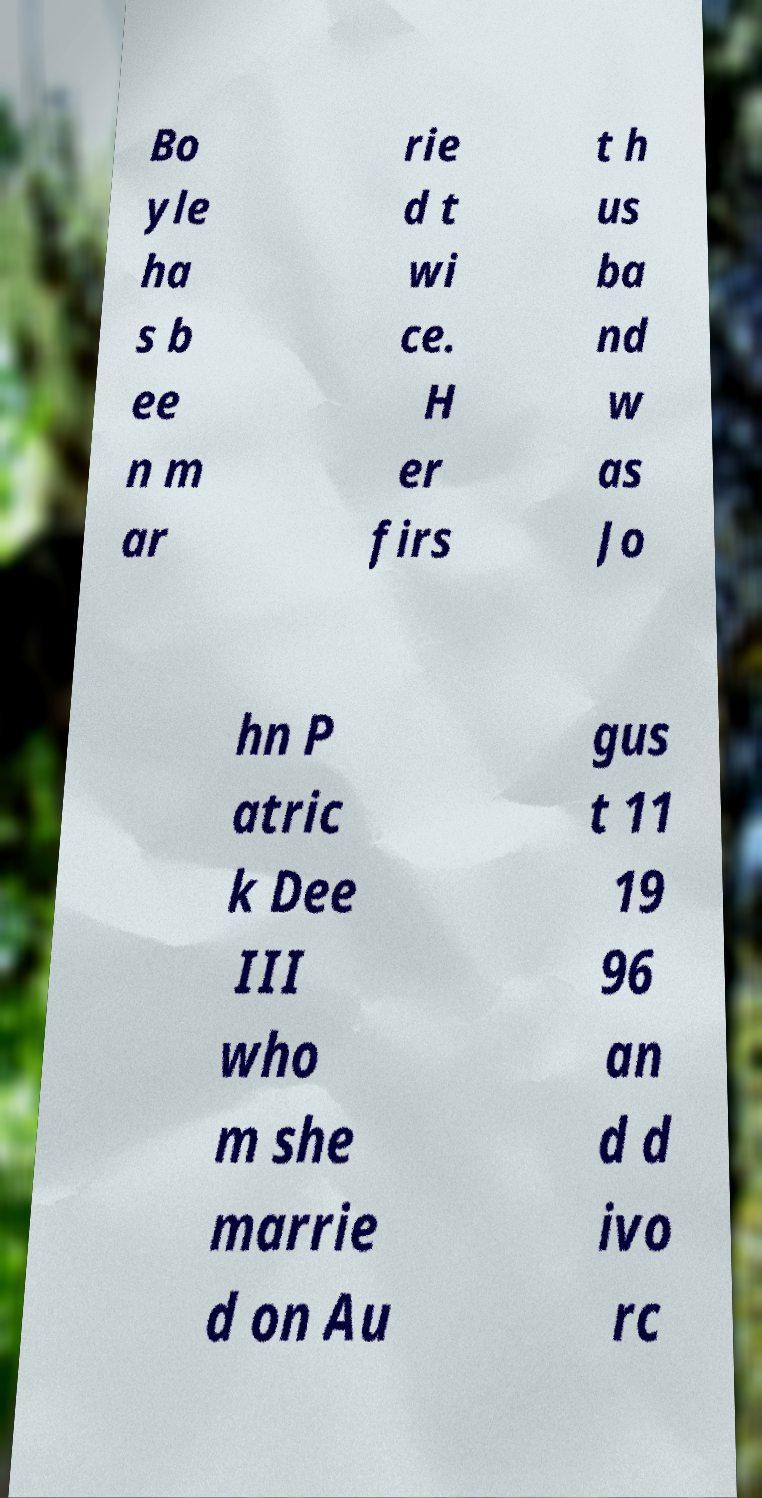Could you extract and type out the text from this image? Bo yle ha s b ee n m ar rie d t wi ce. H er firs t h us ba nd w as Jo hn P atric k Dee III who m she marrie d on Au gus t 11 19 96 an d d ivo rc 